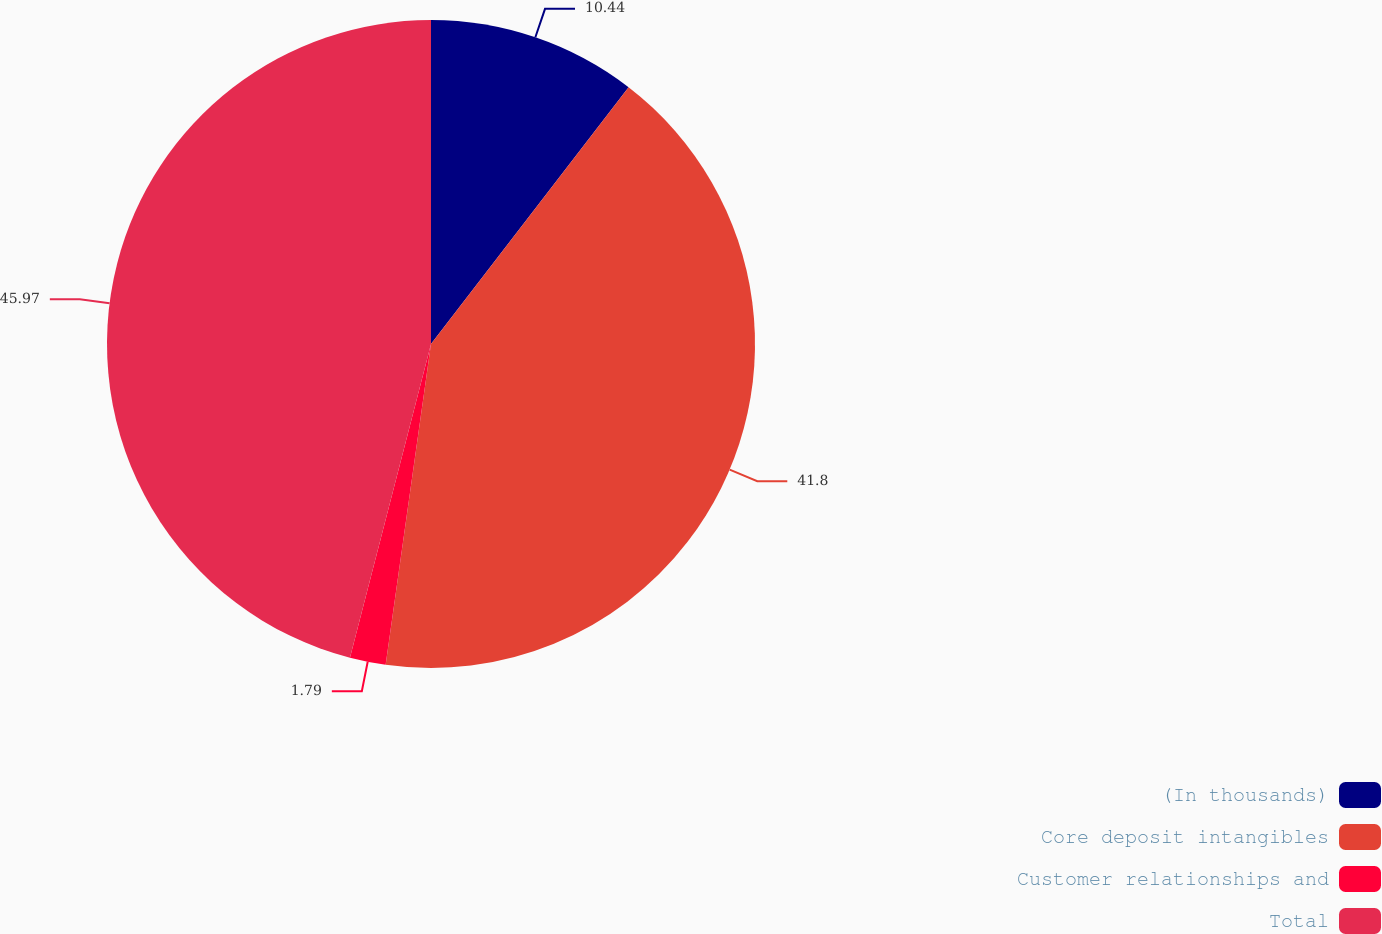<chart> <loc_0><loc_0><loc_500><loc_500><pie_chart><fcel>(In thousands)<fcel>Core deposit intangibles<fcel>Customer relationships and<fcel>Total<nl><fcel>10.44%<fcel>41.8%<fcel>1.79%<fcel>45.98%<nl></chart> 